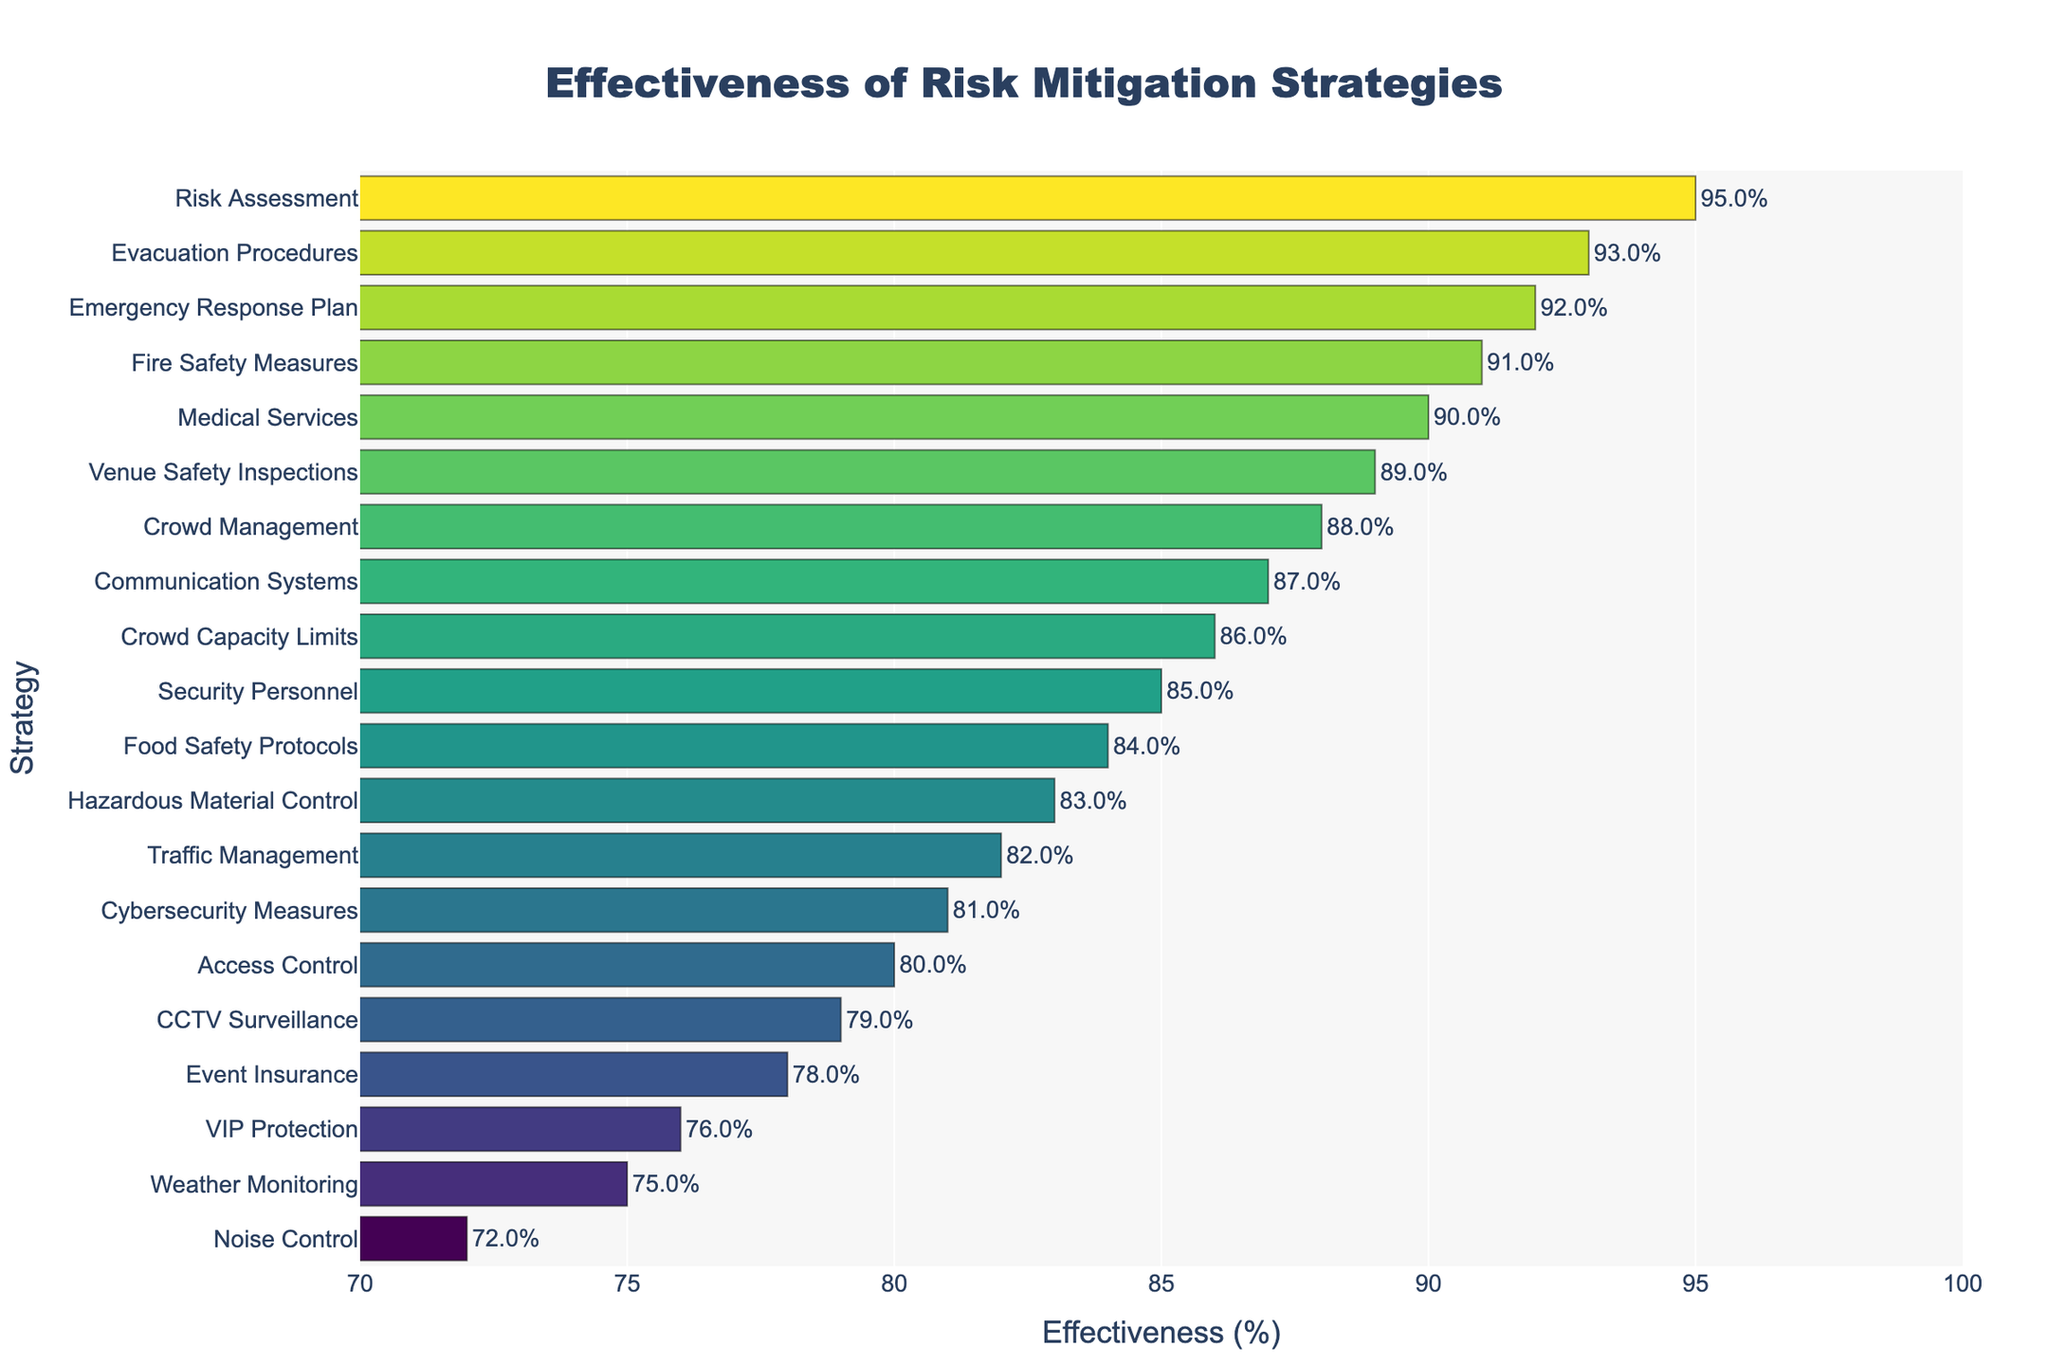What's the most effective risk mitigation strategy? To identify the most effective strategy, look for the bar with the highest percentage on the x-axis. Risk Assessment has an effectiveness of 95%, which is the highest among all strategies.
Answer: Risk Assessment Which two strategies have the least effectiveness and what are their percentages? To find the least effective strategies, look for the two shortest bars on the plot. Weather Monitoring and Noise Control have percentages of 75% and 72% respectively.
Answer: Weather Monitoring (75%), Noise Control (72%) What is the difference in effectiveness between the strategies Event Insurance and Crowd Management? For this, subtract the percentage effectiveness of Event Insurance from that of Crowd Management. Crowd Management is 88% and Event Insurance is 78%, so the difference is 88% - 78% = 10%.
Answer: 10% Which strategies have an effectiveness between 80% and 85%? Look for bars that fall within the 80%-85% range on the x-axis. The strategies are Access Control (80%), VIP Protection (81%), Cybersecurity Measures (81%), Traffic Management (82%), and Food Safety Protocols (84%).
Answer: Access Control (80%), VIP Protection (81%), Cybersecurity Measures (81%), Traffic Management (82%), Food Safety Protocols (84%) Is Fire Safety Measures more effective than Venue Safety Inspections? Compare the lengths of the bars for Fire Safety Measures and Venue Safety Inspections. Fire Safety Measures has an effectiveness of 91% and Venue Safety Inspections has 89%, so Fire Safety Measures is more effective.
Answer: Yes What is the median effectiveness of all the strategies? To find the median, first list all effectiveness percentages in ascending order and then identify the middle value. Ordered percentages: 72, 75, 76, 78, 79, 80, 81, 82, 83, 84, 85, 86, 87, 88, 89, 90, 91, 92, 93, 95. There are 20 values, so the median is the average of the 10th and 11th values, (84 + 85)/2 = 84.5%.
Answer: 84.5% How many strategies have an effectiveness of 90% or higher, and what are they? Count the number of bars that extend to 90% or higher on the x-axis. The strategies are: Emergency Response Plan (92%), Medical Services (90%), Evacuation Procedures (93%), Fire Safety Measures (91%), and Risk Assessment (95%). There are 5 strategies in total.
Answer: 5 strategies: Emergency Response Plan, Medical Services, Evacuation Procedures, Fire Safety Measures, Risk Assessment Which strategy has effectiveness closest to the average effectiveness of all strategies? First, find the average effectiveness by summing all percentages and dividing by the number of strategies. Sum = 85 + 92 + 88 + 80 + 87 + 95 + 78 + 82 + 90 + 75 + 89 + 93 + 86 + 79 + 91 + 83 + 76 + 81 + 84 + 72 = 1716. Average = 1716 / 20 = 85.8%. The closest strategy to 85.8% is Security Personnel with an effectiveness of 85%.
Answer: Security Personnel 